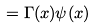<formula> <loc_0><loc_0><loc_500><loc_500>\, = \Gamma ( x ) \psi ( x )</formula> 